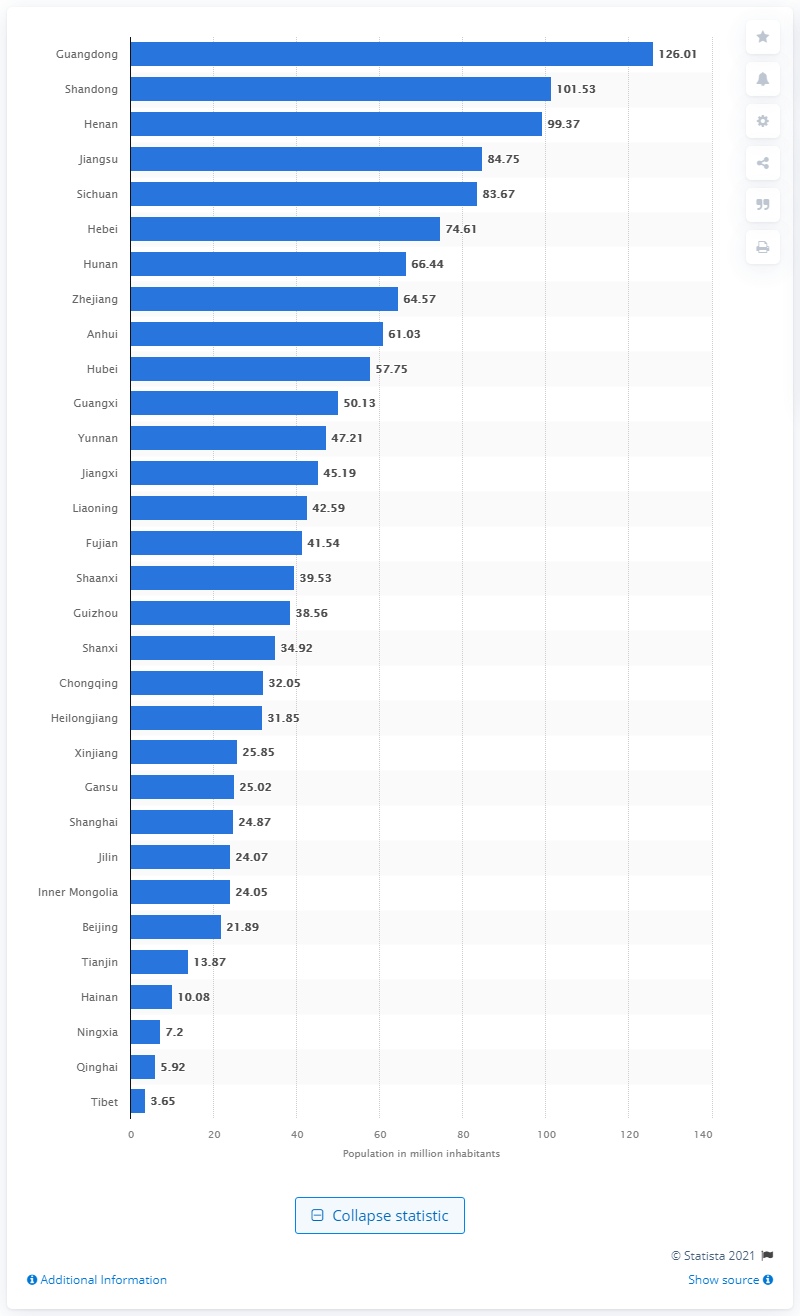Outline some significant characteristics in this image. In the year 2020, an estimated 126.01 million people lived in Guangdong province. In 2020, the sparsely populated highlands of Tibet were home to approximately 3.65 people. 